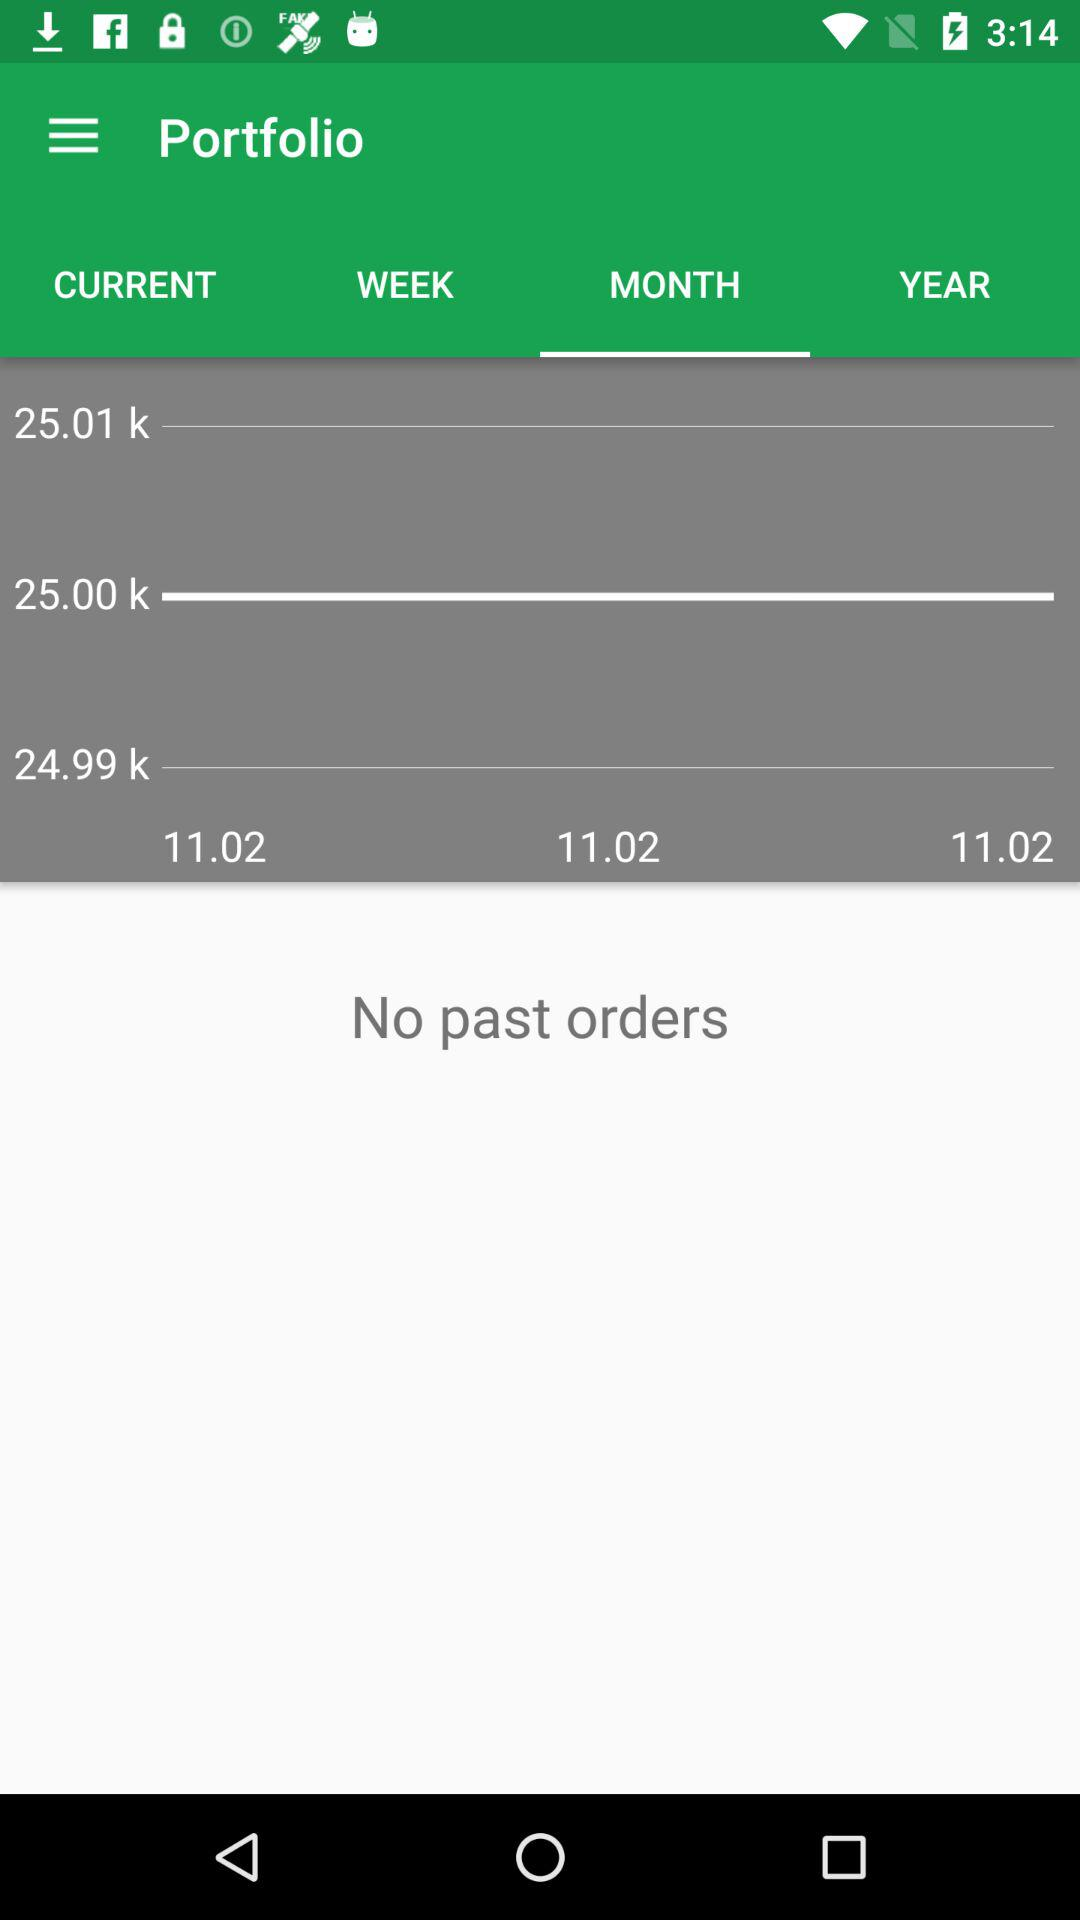How many different prices are there?
Answer the question using a single word or phrase. 3 